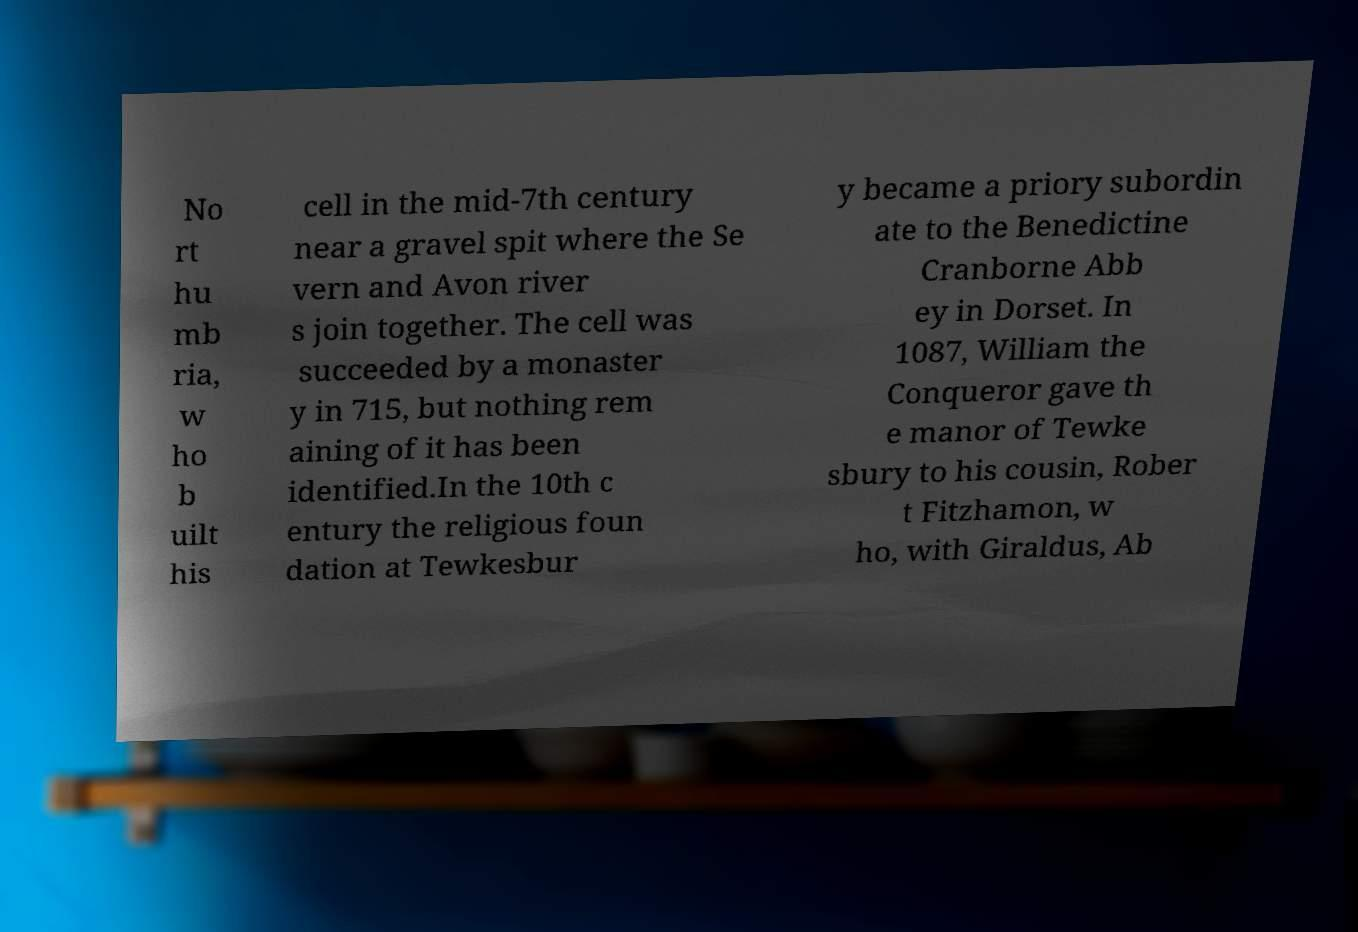Can you read and provide the text displayed in the image?This photo seems to have some interesting text. Can you extract and type it out for me? No rt hu mb ria, w ho b uilt his cell in the mid-7th century near a gravel spit where the Se vern and Avon river s join together. The cell was succeeded by a monaster y in 715, but nothing rem aining of it has been identified.In the 10th c entury the religious foun dation at Tewkesbur y became a priory subordin ate to the Benedictine Cranborne Abb ey in Dorset. In 1087, William the Conqueror gave th e manor of Tewke sbury to his cousin, Rober t Fitzhamon, w ho, with Giraldus, Ab 